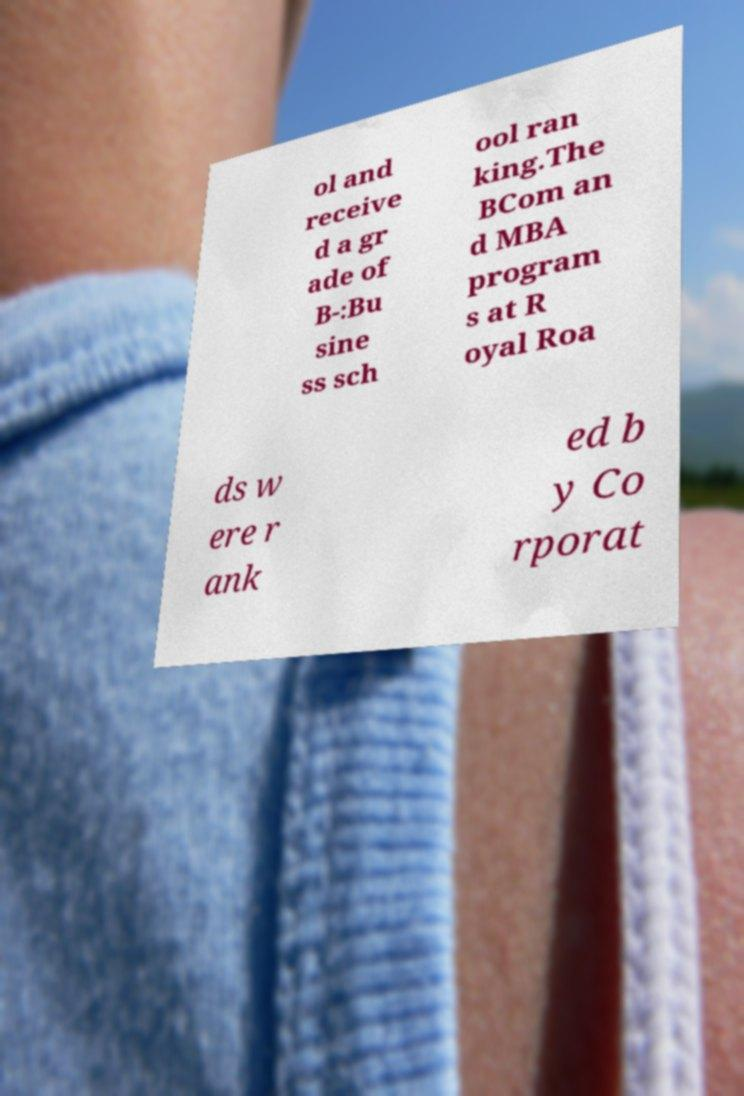There's text embedded in this image that I need extracted. Can you transcribe it verbatim? ol and receive d a gr ade of B-:Bu sine ss sch ool ran king.The BCom an d MBA program s at R oyal Roa ds w ere r ank ed b y Co rporat 